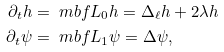Convert formula to latex. <formula><loc_0><loc_0><loc_500><loc_500>\partial _ { t } h & = \ m b f { L } _ { 0 } h = \Delta _ { \ell } h + 2 \lambda h \\ \partial _ { t } \psi & = \ m b f { L } _ { 1 } \psi = \Delta \psi ,</formula> 